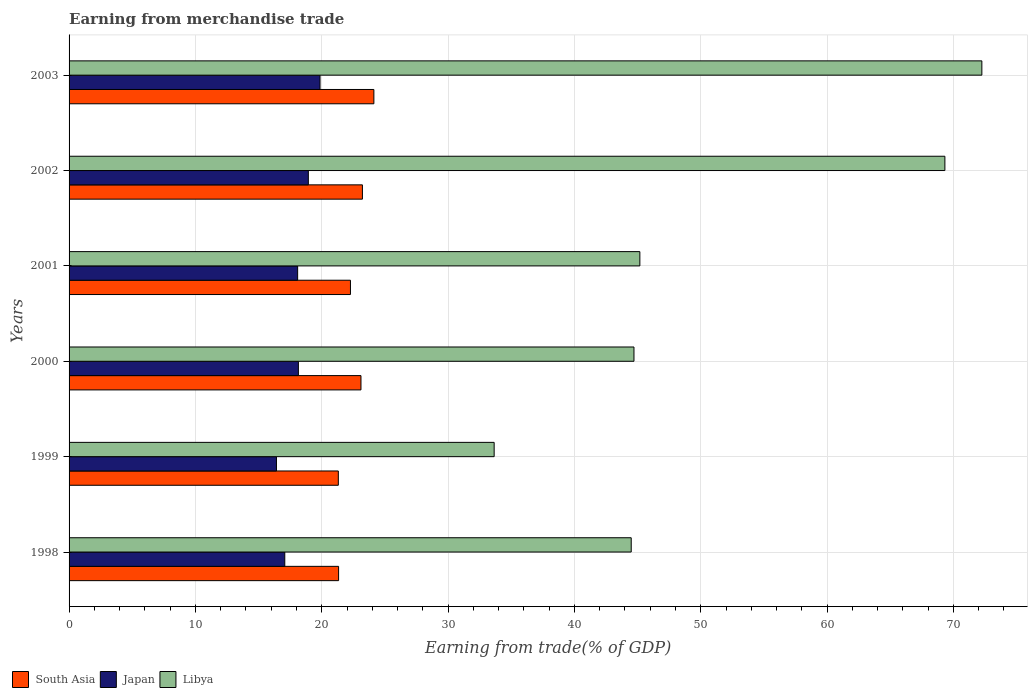How many groups of bars are there?
Your response must be concise. 6. Are the number of bars per tick equal to the number of legend labels?
Keep it short and to the point. Yes. Are the number of bars on each tick of the Y-axis equal?
Provide a short and direct response. Yes. How many bars are there on the 6th tick from the bottom?
Your response must be concise. 3. In how many cases, is the number of bars for a given year not equal to the number of legend labels?
Ensure brevity in your answer.  0. What is the earnings from trade in South Asia in 2003?
Keep it short and to the point. 24.13. Across all years, what is the maximum earnings from trade in Libya?
Offer a terse response. 72.25. Across all years, what is the minimum earnings from trade in Libya?
Keep it short and to the point. 33.65. What is the total earnings from trade in Japan in the graph?
Offer a terse response. 108.54. What is the difference between the earnings from trade in Libya in 1998 and that in 2002?
Provide a short and direct response. -24.83. What is the difference between the earnings from trade in South Asia in 2000 and the earnings from trade in Japan in 2001?
Keep it short and to the point. 5.01. What is the average earnings from trade in Libya per year?
Your response must be concise. 51.6. In the year 2000, what is the difference between the earnings from trade in Japan and earnings from trade in Libya?
Offer a terse response. -26.56. In how many years, is the earnings from trade in Libya greater than 22 %?
Make the answer very short. 6. What is the ratio of the earnings from trade in Libya in 2000 to that in 2001?
Your answer should be compact. 0.99. What is the difference between the highest and the second highest earnings from trade in Japan?
Offer a very short reply. 0.93. What is the difference between the highest and the lowest earnings from trade in Japan?
Make the answer very short. 3.45. What does the 2nd bar from the top in 2001 represents?
Your response must be concise. Japan. What does the 3rd bar from the bottom in 2001 represents?
Your response must be concise. Libya. Is it the case that in every year, the sum of the earnings from trade in South Asia and earnings from trade in Japan is greater than the earnings from trade in Libya?
Your answer should be very brief. No. Are all the bars in the graph horizontal?
Provide a short and direct response. Yes. How many years are there in the graph?
Make the answer very short. 6. Are the values on the major ticks of X-axis written in scientific E-notation?
Ensure brevity in your answer.  No. Does the graph contain grids?
Provide a succinct answer. Yes. How many legend labels are there?
Give a very brief answer. 3. How are the legend labels stacked?
Offer a very short reply. Horizontal. What is the title of the graph?
Your response must be concise. Earning from merchandise trade. Does "Bermuda" appear as one of the legend labels in the graph?
Your answer should be compact. No. What is the label or title of the X-axis?
Make the answer very short. Earning from trade(% of GDP). What is the label or title of the Y-axis?
Make the answer very short. Years. What is the Earning from trade(% of GDP) of South Asia in 1998?
Offer a terse response. 21.33. What is the Earning from trade(% of GDP) in Japan in 1998?
Offer a terse response. 17.07. What is the Earning from trade(% of GDP) in Libya in 1998?
Your answer should be compact. 44.5. What is the Earning from trade(% of GDP) in South Asia in 1999?
Offer a very short reply. 21.31. What is the Earning from trade(% of GDP) of Japan in 1999?
Offer a terse response. 16.41. What is the Earning from trade(% of GDP) of Libya in 1999?
Offer a very short reply. 33.65. What is the Earning from trade(% of GDP) of South Asia in 2000?
Offer a very short reply. 23.1. What is the Earning from trade(% of GDP) of Japan in 2000?
Offer a very short reply. 18.15. What is the Earning from trade(% of GDP) of Libya in 2000?
Make the answer very short. 44.71. What is the Earning from trade(% of GDP) of South Asia in 2001?
Ensure brevity in your answer.  22.27. What is the Earning from trade(% of GDP) of Japan in 2001?
Ensure brevity in your answer.  18.09. What is the Earning from trade(% of GDP) in Libya in 2001?
Give a very brief answer. 45.18. What is the Earning from trade(% of GDP) of South Asia in 2002?
Keep it short and to the point. 23.22. What is the Earning from trade(% of GDP) in Japan in 2002?
Your answer should be very brief. 18.94. What is the Earning from trade(% of GDP) of Libya in 2002?
Provide a succinct answer. 69.32. What is the Earning from trade(% of GDP) in South Asia in 2003?
Make the answer very short. 24.13. What is the Earning from trade(% of GDP) of Japan in 2003?
Your answer should be very brief. 19.86. What is the Earning from trade(% of GDP) of Libya in 2003?
Your answer should be compact. 72.25. Across all years, what is the maximum Earning from trade(% of GDP) of South Asia?
Make the answer very short. 24.13. Across all years, what is the maximum Earning from trade(% of GDP) of Japan?
Your answer should be compact. 19.86. Across all years, what is the maximum Earning from trade(% of GDP) of Libya?
Offer a very short reply. 72.25. Across all years, what is the minimum Earning from trade(% of GDP) in South Asia?
Keep it short and to the point. 21.31. Across all years, what is the minimum Earning from trade(% of GDP) in Japan?
Give a very brief answer. 16.41. Across all years, what is the minimum Earning from trade(% of GDP) in Libya?
Keep it short and to the point. 33.65. What is the total Earning from trade(% of GDP) in South Asia in the graph?
Give a very brief answer. 135.37. What is the total Earning from trade(% of GDP) in Japan in the graph?
Offer a very short reply. 108.54. What is the total Earning from trade(% of GDP) in Libya in the graph?
Provide a short and direct response. 309.61. What is the difference between the Earning from trade(% of GDP) in South Asia in 1998 and that in 1999?
Your answer should be very brief. 0.02. What is the difference between the Earning from trade(% of GDP) of Japan in 1998 and that in 1999?
Offer a very short reply. 0.66. What is the difference between the Earning from trade(% of GDP) in Libya in 1998 and that in 1999?
Ensure brevity in your answer.  10.85. What is the difference between the Earning from trade(% of GDP) in South Asia in 1998 and that in 2000?
Your response must be concise. -1.77. What is the difference between the Earning from trade(% of GDP) in Japan in 1998 and that in 2000?
Your response must be concise. -1.08. What is the difference between the Earning from trade(% of GDP) in Libya in 1998 and that in 2000?
Make the answer very short. -0.22. What is the difference between the Earning from trade(% of GDP) in South Asia in 1998 and that in 2001?
Provide a short and direct response. -0.94. What is the difference between the Earning from trade(% of GDP) in Japan in 1998 and that in 2001?
Give a very brief answer. -1.02. What is the difference between the Earning from trade(% of GDP) of Libya in 1998 and that in 2001?
Make the answer very short. -0.68. What is the difference between the Earning from trade(% of GDP) of South Asia in 1998 and that in 2002?
Your response must be concise. -1.89. What is the difference between the Earning from trade(% of GDP) of Japan in 1998 and that in 2002?
Your answer should be very brief. -1.86. What is the difference between the Earning from trade(% of GDP) of Libya in 1998 and that in 2002?
Ensure brevity in your answer.  -24.83. What is the difference between the Earning from trade(% of GDP) of South Asia in 1998 and that in 2003?
Your answer should be very brief. -2.79. What is the difference between the Earning from trade(% of GDP) in Japan in 1998 and that in 2003?
Your response must be concise. -2.79. What is the difference between the Earning from trade(% of GDP) in Libya in 1998 and that in 2003?
Offer a very short reply. -27.75. What is the difference between the Earning from trade(% of GDP) in South Asia in 1999 and that in 2000?
Your answer should be very brief. -1.79. What is the difference between the Earning from trade(% of GDP) in Japan in 1999 and that in 2000?
Offer a very short reply. -1.74. What is the difference between the Earning from trade(% of GDP) in Libya in 1999 and that in 2000?
Your answer should be very brief. -11.07. What is the difference between the Earning from trade(% of GDP) of South Asia in 1999 and that in 2001?
Make the answer very short. -0.96. What is the difference between the Earning from trade(% of GDP) of Japan in 1999 and that in 2001?
Your response must be concise. -1.68. What is the difference between the Earning from trade(% of GDP) in Libya in 1999 and that in 2001?
Ensure brevity in your answer.  -11.53. What is the difference between the Earning from trade(% of GDP) of South Asia in 1999 and that in 2002?
Your answer should be very brief. -1.91. What is the difference between the Earning from trade(% of GDP) of Japan in 1999 and that in 2002?
Give a very brief answer. -2.52. What is the difference between the Earning from trade(% of GDP) in Libya in 1999 and that in 2002?
Provide a short and direct response. -35.68. What is the difference between the Earning from trade(% of GDP) of South Asia in 1999 and that in 2003?
Keep it short and to the point. -2.81. What is the difference between the Earning from trade(% of GDP) in Japan in 1999 and that in 2003?
Offer a terse response. -3.45. What is the difference between the Earning from trade(% of GDP) of Libya in 1999 and that in 2003?
Your answer should be very brief. -38.6. What is the difference between the Earning from trade(% of GDP) in South Asia in 2000 and that in 2001?
Offer a very short reply. 0.83. What is the difference between the Earning from trade(% of GDP) in Japan in 2000 and that in 2001?
Your answer should be very brief. 0.06. What is the difference between the Earning from trade(% of GDP) of Libya in 2000 and that in 2001?
Your answer should be very brief. -0.47. What is the difference between the Earning from trade(% of GDP) of South Asia in 2000 and that in 2002?
Offer a very short reply. -0.11. What is the difference between the Earning from trade(% of GDP) of Japan in 2000 and that in 2002?
Keep it short and to the point. -0.79. What is the difference between the Earning from trade(% of GDP) in Libya in 2000 and that in 2002?
Make the answer very short. -24.61. What is the difference between the Earning from trade(% of GDP) of South Asia in 2000 and that in 2003?
Offer a very short reply. -1.02. What is the difference between the Earning from trade(% of GDP) of Japan in 2000 and that in 2003?
Make the answer very short. -1.71. What is the difference between the Earning from trade(% of GDP) in Libya in 2000 and that in 2003?
Your response must be concise. -27.54. What is the difference between the Earning from trade(% of GDP) of South Asia in 2001 and that in 2002?
Offer a terse response. -0.95. What is the difference between the Earning from trade(% of GDP) of Japan in 2001 and that in 2002?
Provide a succinct answer. -0.85. What is the difference between the Earning from trade(% of GDP) in Libya in 2001 and that in 2002?
Provide a succinct answer. -24.14. What is the difference between the Earning from trade(% of GDP) in South Asia in 2001 and that in 2003?
Your answer should be very brief. -1.85. What is the difference between the Earning from trade(% of GDP) in Japan in 2001 and that in 2003?
Offer a terse response. -1.77. What is the difference between the Earning from trade(% of GDP) in Libya in 2001 and that in 2003?
Provide a succinct answer. -27.07. What is the difference between the Earning from trade(% of GDP) of South Asia in 2002 and that in 2003?
Keep it short and to the point. -0.91. What is the difference between the Earning from trade(% of GDP) of Japan in 2002 and that in 2003?
Make the answer very short. -0.93. What is the difference between the Earning from trade(% of GDP) in Libya in 2002 and that in 2003?
Offer a terse response. -2.93. What is the difference between the Earning from trade(% of GDP) in South Asia in 1998 and the Earning from trade(% of GDP) in Japan in 1999?
Provide a short and direct response. 4.92. What is the difference between the Earning from trade(% of GDP) of South Asia in 1998 and the Earning from trade(% of GDP) of Libya in 1999?
Ensure brevity in your answer.  -12.31. What is the difference between the Earning from trade(% of GDP) of Japan in 1998 and the Earning from trade(% of GDP) of Libya in 1999?
Make the answer very short. -16.57. What is the difference between the Earning from trade(% of GDP) of South Asia in 1998 and the Earning from trade(% of GDP) of Japan in 2000?
Offer a very short reply. 3.18. What is the difference between the Earning from trade(% of GDP) in South Asia in 1998 and the Earning from trade(% of GDP) in Libya in 2000?
Your response must be concise. -23.38. What is the difference between the Earning from trade(% of GDP) in Japan in 1998 and the Earning from trade(% of GDP) in Libya in 2000?
Your response must be concise. -27.64. What is the difference between the Earning from trade(% of GDP) in South Asia in 1998 and the Earning from trade(% of GDP) in Japan in 2001?
Provide a short and direct response. 3.24. What is the difference between the Earning from trade(% of GDP) of South Asia in 1998 and the Earning from trade(% of GDP) of Libya in 2001?
Give a very brief answer. -23.85. What is the difference between the Earning from trade(% of GDP) of Japan in 1998 and the Earning from trade(% of GDP) of Libya in 2001?
Give a very brief answer. -28.11. What is the difference between the Earning from trade(% of GDP) in South Asia in 1998 and the Earning from trade(% of GDP) in Japan in 2002?
Your response must be concise. 2.4. What is the difference between the Earning from trade(% of GDP) of South Asia in 1998 and the Earning from trade(% of GDP) of Libya in 2002?
Provide a succinct answer. -47.99. What is the difference between the Earning from trade(% of GDP) in Japan in 1998 and the Earning from trade(% of GDP) in Libya in 2002?
Make the answer very short. -52.25. What is the difference between the Earning from trade(% of GDP) in South Asia in 1998 and the Earning from trade(% of GDP) in Japan in 2003?
Provide a succinct answer. 1.47. What is the difference between the Earning from trade(% of GDP) in South Asia in 1998 and the Earning from trade(% of GDP) in Libya in 2003?
Keep it short and to the point. -50.92. What is the difference between the Earning from trade(% of GDP) of Japan in 1998 and the Earning from trade(% of GDP) of Libya in 2003?
Your response must be concise. -55.18. What is the difference between the Earning from trade(% of GDP) of South Asia in 1999 and the Earning from trade(% of GDP) of Japan in 2000?
Your answer should be compact. 3.16. What is the difference between the Earning from trade(% of GDP) of South Asia in 1999 and the Earning from trade(% of GDP) of Libya in 2000?
Ensure brevity in your answer.  -23.4. What is the difference between the Earning from trade(% of GDP) in Japan in 1999 and the Earning from trade(% of GDP) in Libya in 2000?
Your response must be concise. -28.3. What is the difference between the Earning from trade(% of GDP) in South Asia in 1999 and the Earning from trade(% of GDP) in Japan in 2001?
Your answer should be very brief. 3.22. What is the difference between the Earning from trade(% of GDP) of South Asia in 1999 and the Earning from trade(% of GDP) of Libya in 2001?
Provide a succinct answer. -23.87. What is the difference between the Earning from trade(% of GDP) in Japan in 1999 and the Earning from trade(% of GDP) in Libya in 2001?
Your answer should be compact. -28.77. What is the difference between the Earning from trade(% of GDP) of South Asia in 1999 and the Earning from trade(% of GDP) of Japan in 2002?
Your answer should be very brief. 2.37. What is the difference between the Earning from trade(% of GDP) in South Asia in 1999 and the Earning from trade(% of GDP) in Libya in 2002?
Keep it short and to the point. -48.01. What is the difference between the Earning from trade(% of GDP) in Japan in 1999 and the Earning from trade(% of GDP) in Libya in 2002?
Your answer should be compact. -52.91. What is the difference between the Earning from trade(% of GDP) in South Asia in 1999 and the Earning from trade(% of GDP) in Japan in 2003?
Give a very brief answer. 1.45. What is the difference between the Earning from trade(% of GDP) in South Asia in 1999 and the Earning from trade(% of GDP) in Libya in 2003?
Your answer should be very brief. -50.94. What is the difference between the Earning from trade(% of GDP) in Japan in 1999 and the Earning from trade(% of GDP) in Libya in 2003?
Make the answer very short. -55.84. What is the difference between the Earning from trade(% of GDP) in South Asia in 2000 and the Earning from trade(% of GDP) in Japan in 2001?
Your response must be concise. 5.01. What is the difference between the Earning from trade(% of GDP) in South Asia in 2000 and the Earning from trade(% of GDP) in Libya in 2001?
Your answer should be very brief. -22.08. What is the difference between the Earning from trade(% of GDP) of Japan in 2000 and the Earning from trade(% of GDP) of Libya in 2001?
Provide a short and direct response. -27.03. What is the difference between the Earning from trade(% of GDP) of South Asia in 2000 and the Earning from trade(% of GDP) of Japan in 2002?
Provide a short and direct response. 4.17. What is the difference between the Earning from trade(% of GDP) in South Asia in 2000 and the Earning from trade(% of GDP) in Libya in 2002?
Offer a terse response. -46.22. What is the difference between the Earning from trade(% of GDP) of Japan in 2000 and the Earning from trade(% of GDP) of Libya in 2002?
Your answer should be very brief. -51.17. What is the difference between the Earning from trade(% of GDP) of South Asia in 2000 and the Earning from trade(% of GDP) of Japan in 2003?
Your answer should be very brief. 3.24. What is the difference between the Earning from trade(% of GDP) of South Asia in 2000 and the Earning from trade(% of GDP) of Libya in 2003?
Give a very brief answer. -49.15. What is the difference between the Earning from trade(% of GDP) in Japan in 2000 and the Earning from trade(% of GDP) in Libya in 2003?
Provide a short and direct response. -54.1. What is the difference between the Earning from trade(% of GDP) of South Asia in 2001 and the Earning from trade(% of GDP) of Japan in 2002?
Keep it short and to the point. 3.33. What is the difference between the Earning from trade(% of GDP) of South Asia in 2001 and the Earning from trade(% of GDP) of Libya in 2002?
Keep it short and to the point. -47.05. What is the difference between the Earning from trade(% of GDP) in Japan in 2001 and the Earning from trade(% of GDP) in Libya in 2002?
Provide a short and direct response. -51.23. What is the difference between the Earning from trade(% of GDP) in South Asia in 2001 and the Earning from trade(% of GDP) in Japan in 2003?
Provide a short and direct response. 2.41. What is the difference between the Earning from trade(% of GDP) in South Asia in 2001 and the Earning from trade(% of GDP) in Libya in 2003?
Ensure brevity in your answer.  -49.98. What is the difference between the Earning from trade(% of GDP) in Japan in 2001 and the Earning from trade(% of GDP) in Libya in 2003?
Make the answer very short. -54.16. What is the difference between the Earning from trade(% of GDP) in South Asia in 2002 and the Earning from trade(% of GDP) in Japan in 2003?
Your answer should be very brief. 3.36. What is the difference between the Earning from trade(% of GDP) in South Asia in 2002 and the Earning from trade(% of GDP) in Libya in 2003?
Offer a very short reply. -49.03. What is the difference between the Earning from trade(% of GDP) of Japan in 2002 and the Earning from trade(% of GDP) of Libya in 2003?
Give a very brief answer. -53.31. What is the average Earning from trade(% of GDP) in South Asia per year?
Provide a short and direct response. 22.56. What is the average Earning from trade(% of GDP) of Japan per year?
Offer a terse response. 18.09. What is the average Earning from trade(% of GDP) of Libya per year?
Your response must be concise. 51.6. In the year 1998, what is the difference between the Earning from trade(% of GDP) in South Asia and Earning from trade(% of GDP) in Japan?
Your answer should be very brief. 4.26. In the year 1998, what is the difference between the Earning from trade(% of GDP) in South Asia and Earning from trade(% of GDP) in Libya?
Offer a terse response. -23.16. In the year 1998, what is the difference between the Earning from trade(% of GDP) in Japan and Earning from trade(% of GDP) in Libya?
Your answer should be very brief. -27.42. In the year 1999, what is the difference between the Earning from trade(% of GDP) of South Asia and Earning from trade(% of GDP) of Japan?
Offer a terse response. 4.9. In the year 1999, what is the difference between the Earning from trade(% of GDP) of South Asia and Earning from trade(% of GDP) of Libya?
Your answer should be compact. -12.33. In the year 1999, what is the difference between the Earning from trade(% of GDP) of Japan and Earning from trade(% of GDP) of Libya?
Your answer should be very brief. -17.23. In the year 2000, what is the difference between the Earning from trade(% of GDP) of South Asia and Earning from trade(% of GDP) of Japan?
Your answer should be compact. 4.95. In the year 2000, what is the difference between the Earning from trade(% of GDP) of South Asia and Earning from trade(% of GDP) of Libya?
Provide a short and direct response. -21.61. In the year 2000, what is the difference between the Earning from trade(% of GDP) of Japan and Earning from trade(% of GDP) of Libya?
Make the answer very short. -26.56. In the year 2001, what is the difference between the Earning from trade(% of GDP) in South Asia and Earning from trade(% of GDP) in Japan?
Provide a succinct answer. 4.18. In the year 2001, what is the difference between the Earning from trade(% of GDP) in South Asia and Earning from trade(% of GDP) in Libya?
Give a very brief answer. -22.91. In the year 2001, what is the difference between the Earning from trade(% of GDP) of Japan and Earning from trade(% of GDP) of Libya?
Your response must be concise. -27.09. In the year 2002, what is the difference between the Earning from trade(% of GDP) in South Asia and Earning from trade(% of GDP) in Japan?
Provide a succinct answer. 4.28. In the year 2002, what is the difference between the Earning from trade(% of GDP) in South Asia and Earning from trade(% of GDP) in Libya?
Your answer should be very brief. -46.11. In the year 2002, what is the difference between the Earning from trade(% of GDP) in Japan and Earning from trade(% of GDP) in Libya?
Provide a succinct answer. -50.39. In the year 2003, what is the difference between the Earning from trade(% of GDP) of South Asia and Earning from trade(% of GDP) of Japan?
Offer a terse response. 4.26. In the year 2003, what is the difference between the Earning from trade(% of GDP) of South Asia and Earning from trade(% of GDP) of Libya?
Offer a terse response. -48.12. In the year 2003, what is the difference between the Earning from trade(% of GDP) of Japan and Earning from trade(% of GDP) of Libya?
Offer a terse response. -52.39. What is the ratio of the Earning from trade(% of GDP) of South Asia in 1998 to that in 1999?
Make the answer very short. 1. What is the ratio of the Earning from trade(% of GDP) in Japan in 1998 to that in 1999?
Your answer should be compact. 1.04. What is the ratio of the Earning from trade(% of GDP) of Libya in 1998 to that in 1999?
Give a very brief answer. 1.32. What is the ratio of the Earning from trade(% of GDP) of South Asia in 1998 to that in 2000?
Offer a very short reply. 0.92. What is the ratio of the Earning from trade(% of GDP) in Japan in 1998 to that in 2000?
Your response must be concise. 0.94. What is the ratio of the Earning from trade(% of GDP) in South Asia in 1998 to that in 2001?
Provide a succinct answer. 0.96. What is the ratio of the Earning from trade(% of GDP) in Japan in 1998 to that in 2001?
Ensure brevity in your answer.  0.94. What is the ratio of the Earning from trade(% of GDP) in Libya in 1998 to that in 2001?
Give a very brief answer. 0.98. What is the ratio of the Earning from trade(% of GDP) of South Asia in 1998 to that in 2002?
Provide a short and direct response. 0.92. What is the ratio of the Earning from trade(% of GDP) in Japan in 1998 to that in 2002?
Your answer should be very brief. 0.9. What is the ratio of the Earning from trade(% of GDP) of Libya in 1998 to that in 2002?
Provide a short and direct response. 0.64. What is the ratio of the Earning from trade(% of GDP) in South Asia in 1998 to that in 2003?
Give a very brief answer. 0.88. What is the ratio of the Earning from trade(% of GDP) in Japan in 1998 to that in 2003?
Ensure brevity in your answer.  0.86. What is the ratio of the Earning from trade(% of GDP) of Libya in 1998 to that in 2003?
Give a very brief answer. 0.62. What is the ratio of the Earning from trade(% of GDP) in South Asia in 1999 to that in 2000?
Keep it short and to the point. 0.92. What is the ratio of the Earning from trade(% of GDP) of Japan in 1999 to that in 2000?
Your answer should be compact. 0.9. What is the ratio of the Earning from trade(% of GDP) in Libya in 1999 to that in 2000?
Ensure brevity in your answer.  0.75. What is the ratio of the Earning from trade(% of GDP) in South Asia in 1999 to that in 2001?
Keep it short and to the point. 0.96. What is the ratio of the Earning from trade(% of GDP) in Japan in 1999 to that in 2001?
Your response must be concise. 0.91. What is the ratio of the Earning from trade(% of GDP) in Libya in 1999 to that in 2001?
Offer a terse response. 0.74. What is the ratio of the Earning from trade(% of GDP) in South Asia in 1999 to that in 2002?
Give a very brief answer. 0.92. What is the ratio of the Earning from trade(% of GDP) of Japan in 1999 to that in 2002?
Keep it short and to the point. 0.87. What is the ratio of the Earning from trade(% of GDP) in Libya in 1999 to that in 2002?
Provide a short and direct response. 0.49. What is the ratio of the Earning from trade(% of GDP) of South Asia in 1999 to that in 2003?
Your response must be concise. 0.88. What is the ratio of the Earning from trade(% of GDP) in Japan in 1999 to that in 2003?
Provide a succinct answer. 0.83. What is the ratio of the Earning from trade(% of GDP) in Libya in 1999 to that in 2003?
Keep it short and to the point. 0.47. What is the ratio of the Earning from trade(% of GDP) in South Asia in 2000 to that in 2001?
Give a very brief answer. 1.04. What is the ratio of the Earning from trade(% of GDP) in South Asia in 2000 to that in 2002?
Provide a short and direct response. 1. What is the ratio of the Earning from trade(% of GDP) of Japan in 2000 to that in 2002?
Give a very brief answer. 0.96. What is the ratio of the Earning from trade(% of GDP) of Libya in 2000 to that in 2002?
Your answer should be very brief. 0.65. What is the ratio of the Earning from trade(% of GDP) of South Asia in 2000 to that in 2003?
Provide a succinct answer. 0.96. What is the ratio of the Earning from trade(% of GDP) of Japan in 2000 to that in 2003?
Make the answer very short. 0.91. What is the ratio of the Earning from trade(% of GDP) in Libya in 2000 to that in 2003?
Keep it short and to the point. 0.62. What is the ratio of the Earning from trade(% of GDP) in South Asia in 2001 to that in 2002?
Your answer should be compact. 0.96. What is the ratio of the Earning from trade(% of GDP) in Japan in 2001 to that in 2002?
Offer a terse response. 0.96. What is the ratio of the Earning from trade(% of GDP) in Libya in 2001 to that in 2002?
Your answer should be very brief. 0.65. What is the ratio of the Earning from trade(% of GDP) of South Asia in 2001 to that in 2003?
Give a very brief answer. 0.92. What is the ratio of the Earning from trade(% of GDP) in Japan in 2001 to that in 2003?
Your answer should be compact. 0.91. What is the ratio of the Earning from trade(% of GDP) in Libya in 2001 to that in 2003?
Ensure brevity in your answer.  0.63. What is the ratio of the Earning from trade(% of GDP) in South Asia in 2002 to that in 2003?
Your answer should be compact. 0.96. What is the ratio of the Earning from trade(% of GDP) of Japan in 2002 to that in 2003?
Make the answer very short. 0.95. What is the ratio of the Earning from trade(% of GDP) of Libya in 2002 to that in 2003?
Your answer should be very brief. 0.96. What is the difference between the highest and the second highest Earning from trade(% of GDP) of South Asia?
Your response must be concise. 0.91. What is the difference between the highest and the second highest Earning from trade(% of GDP) of Japan?
Make the answer very short. 0.93. What is the difference between the highest and the second highest Earning from trade(% of GDP) in Libya?
Provide a succinct answer. 2.93. What is the difference between the highest and the lowest Earning from trade(% of GDP) of South Asia?
Provide a succinct answer. 2.81. What is the difference between the highest and the lowest Earning from trade(% of GDP) of Japan?
Your answer should be very brief. 3.45. What is the difference between the highest and the lowest Earning from trade(% of GDP) in Libya?
Offer a terse response. 38.6. 